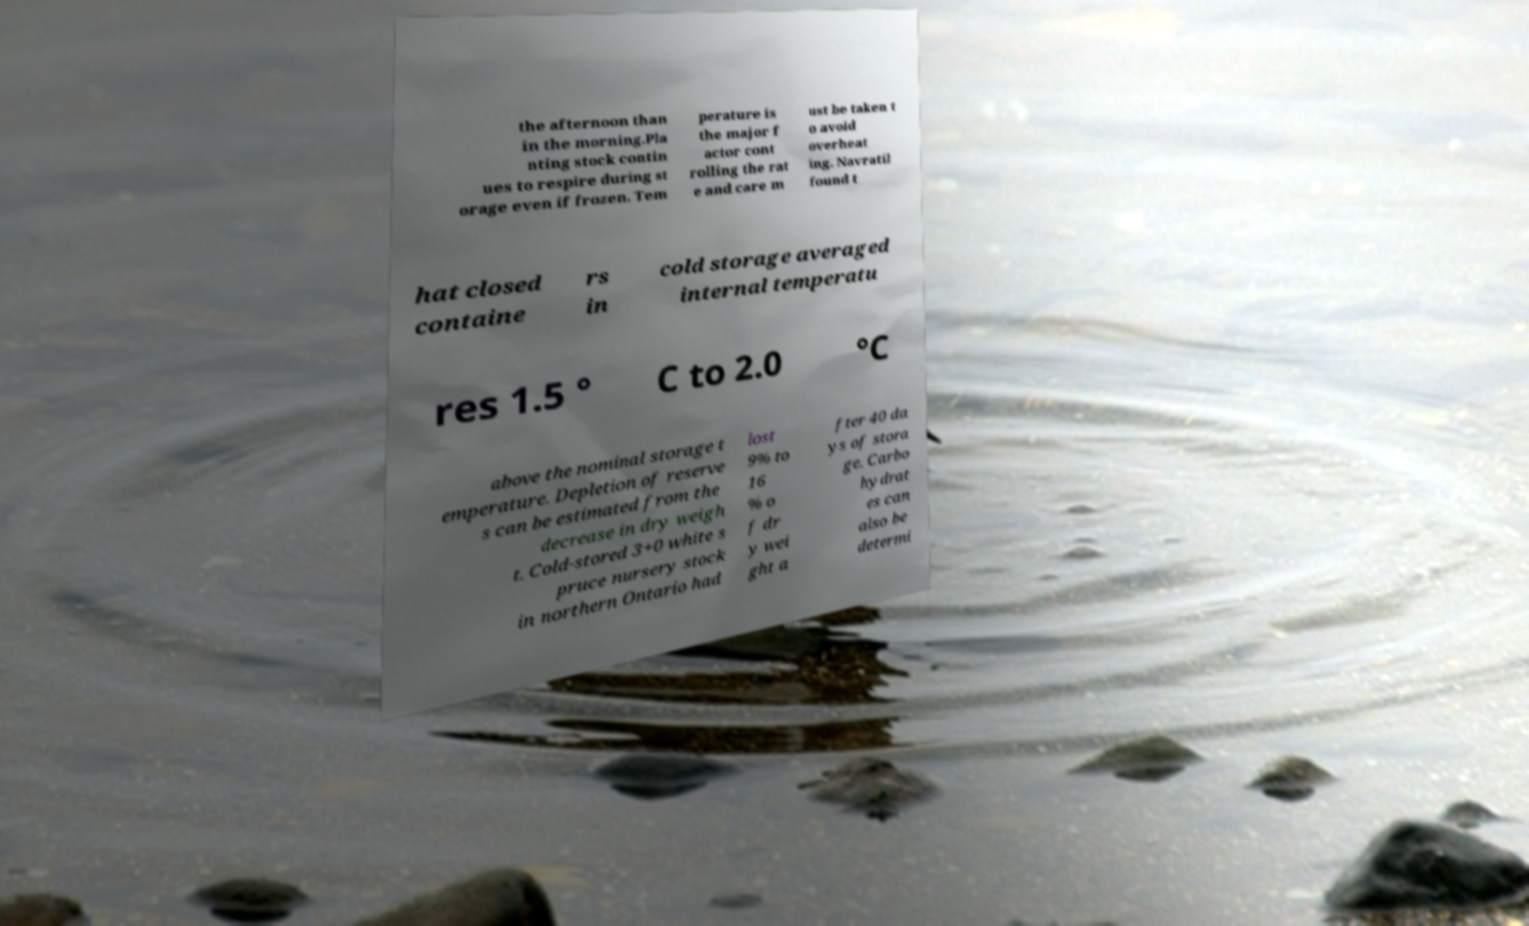Please identify and transcribe the text found in this image. the afternoon than in the morning.Pla nting stock contin ues to respire during st orage even if frozen. Tem perature is the major f actor cont rolling the rat e and care m ust be taken t o avoid overheat ing. Navratil found t hat closed containe rs in cold storage averaged internal temperatu res 1.5 ° C to 2.0 °C above the nominal storage t emperature. Depletion of reserve s can be estimated from the decrease in dry weigh t. Cold-stored 3+0 white s pruce nursery stock in northern Ontario had lost 9% to 16 % o f dr y wei ght a fter 40 da ys of stora ge. Carbo hydrat es can also be determi 